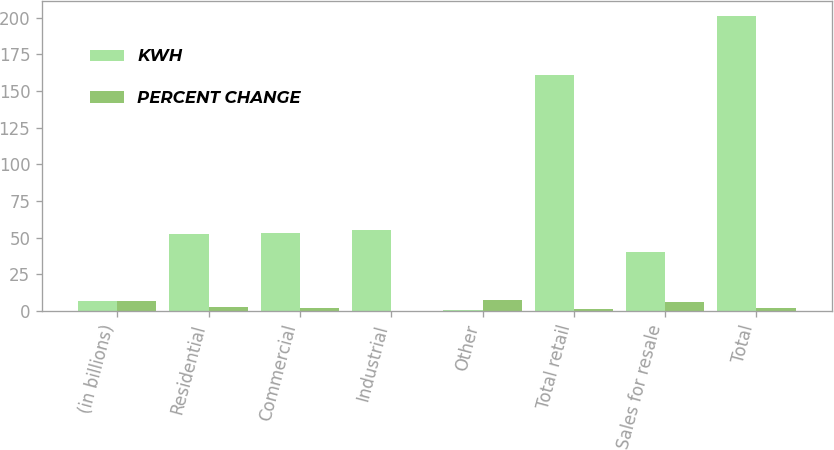Convert chart to OTSL. <chart><loc_0><loc_0><loc_500><loc_500><stacked_bar_chart><ecel><fcel>(in billions)<fcel>Residential<fcel>Commercial<fcel>Industrial<fcel>Other<fcel>Total retail<fcel>Sales for resale<fcel>Total<nl><fcel>KWH<fcel>6.85<fcel>52.4<fcel>53<fcel>55<fcel>0.9<fcel>161.3<fcel>40.1<fcel>201.4<nl><fcel>PERCENT CHANGE<fcel>6.85<fcel>2.5<fcel>2.2<fcel>0.2<fcel>7.6<fcel>1.4<fcel>6.1<fcel>2.3<nl></chart> 